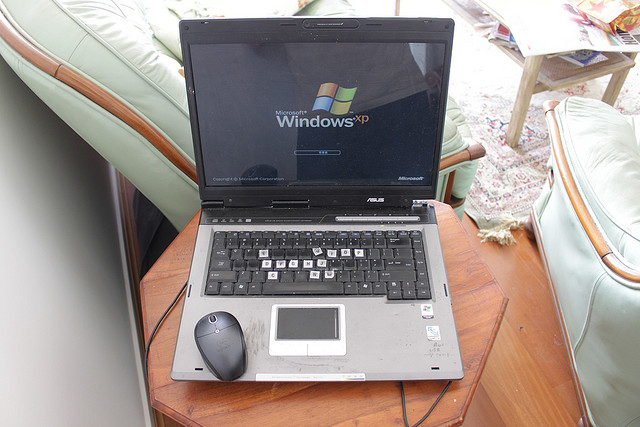Read and extract the text from this image. WINDOWS +xp 